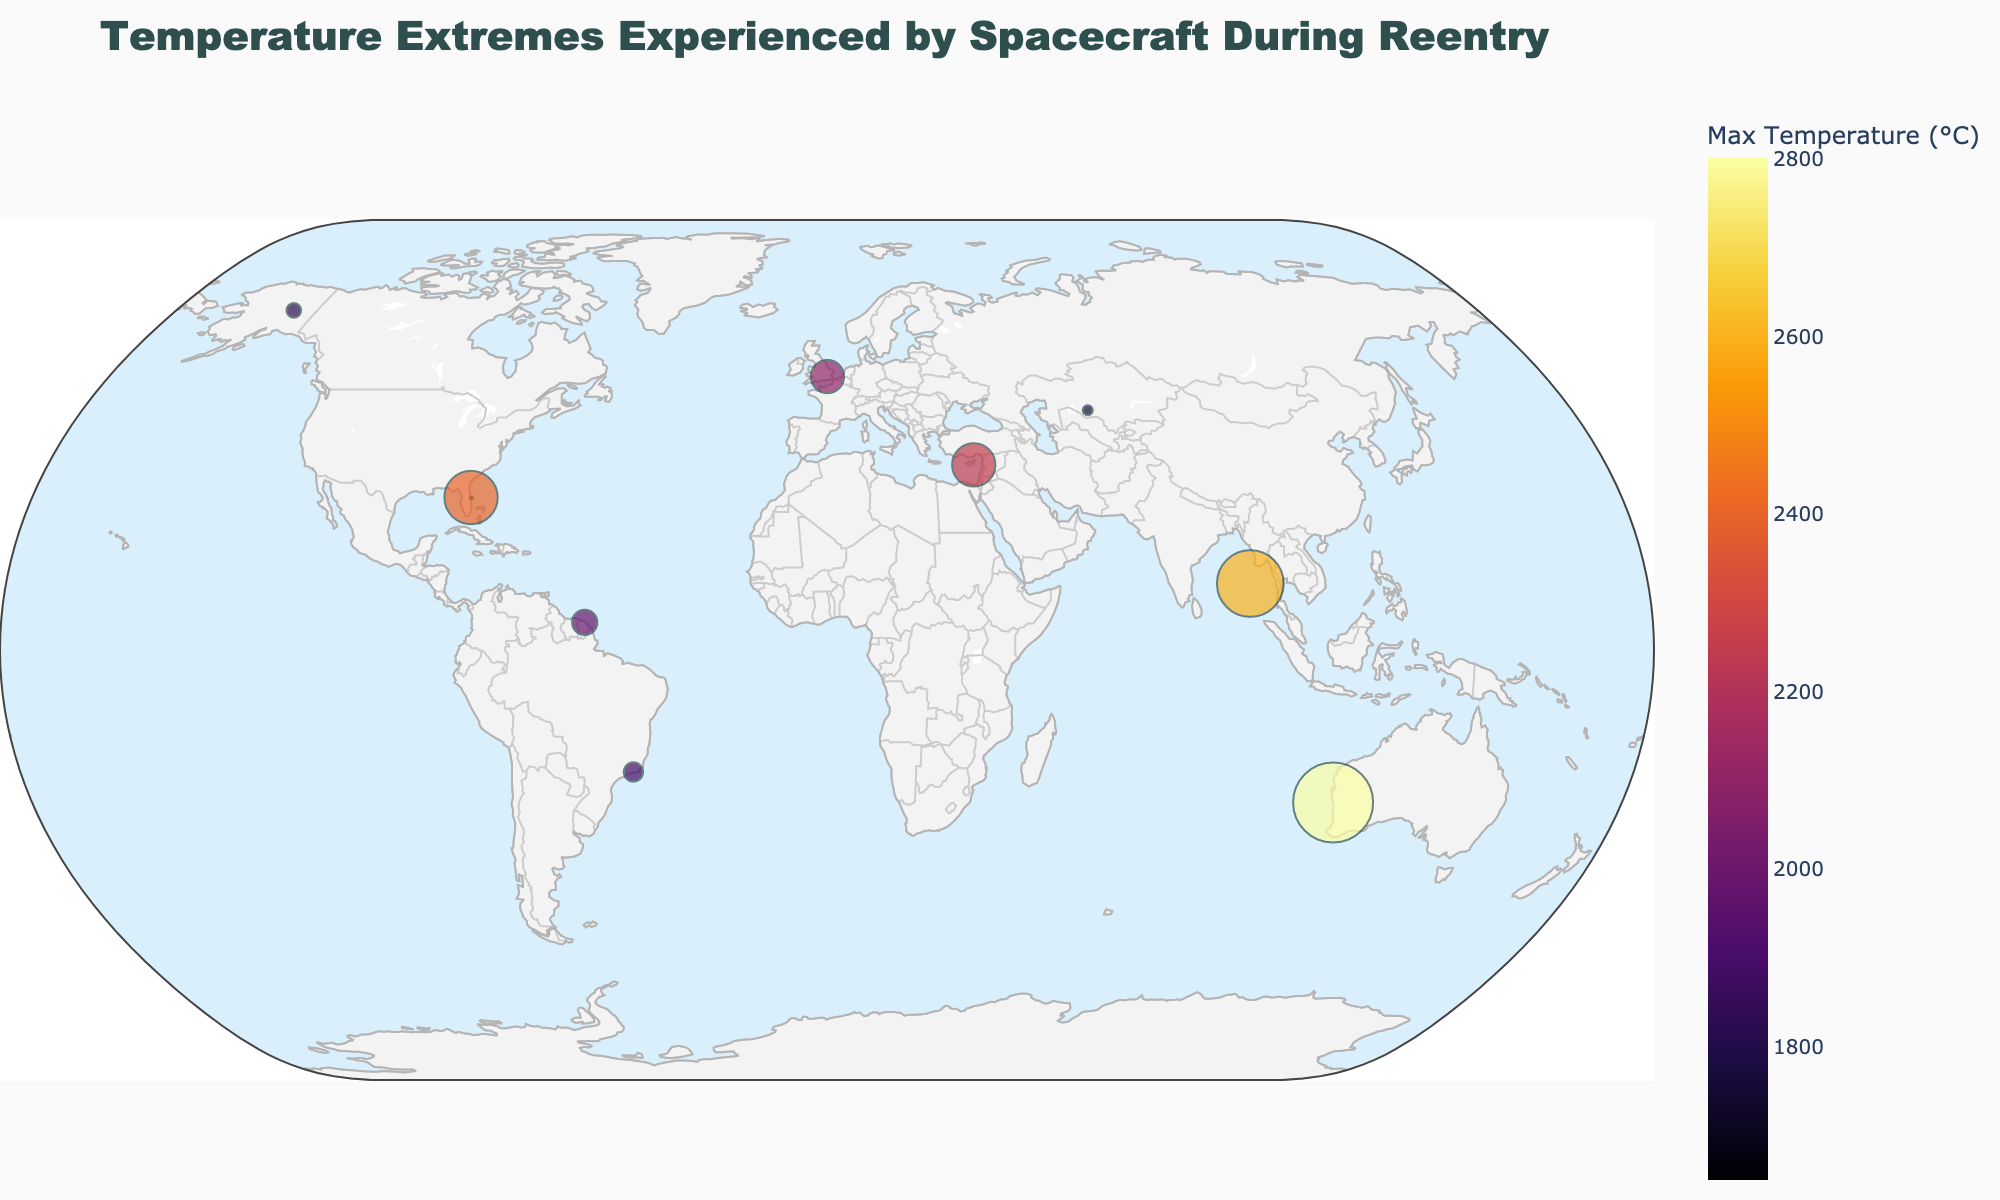What is the title of the plot? The title of the plot is displayed prominently at the top of the figure. It reads "Temperature Extremes Experienced by Spacecraft During Reentry".
Answer: Temperature Extremes Experienced by Spacecraft During Reentry Which orbital path experiences the highest maximum temperature? By examining the plot, we see that the "Mercury Probe Return" datapoint has the highest maximum temperature indicated by the color and the text information.
Answer: Mercury Probe Return How many data points are plotted on the map? We can count the number of markers on the plot, or refer to the data table provided, which lists 10 different orbital paths.
Answer: 10 Which orbital path has the lowest maximum temperature and what is that temperature? The "Low Earth Orbit" has the lowest maximum temperature, as indicated by the plot markers and the text, which shows the lowest value of 1650°C.
Answer: Low Earth Orbit, 1650°C What is the color scale used to represent the temperatures? The figure uses an 'Inferno' color scale to represent the temperatures, transitioning from dark to light colors as the temperature increases.
Answer: Inferno What is the difference in maximum temperature between the "Venus Flyby" and the "Geostationary Transfer Orbit"? From the text information on the plot, "Venus Flyby" has a maximum temperature of 2600°C and "Geostationary Transfer Orbit" has 1980°C. The difference can be calculated as 2600 - 1980.
Answer: 620°C Which three orbital paths have temperatures higher than 2000°C? By analyzing the markers and their respective temperature information on the plot, we identify "Lunar Transfer Orbit" (2250°C), "Mars Transfer Orbit" (2400°C), "Venus Flyby" (2600°C), and "Mercury Probe Return" (2800°C). Therefore, three of these include "Lunar Transfer Orbit", "Mars Transfer Orbit", and "Venus Flyby".
Answer: Lunar Transfer Orbit, Mars Transfer Orbit, Venus Flyby What is the average temperature of the orbital paths? Summing the maximum temperatures from the data and dividing by the number of data points (10): (1650 + 1820 + 1750 + 1980 + 1890 + 2100 + 2250 + 2400 + 2600 + 2800)/10. The exact calculations: the sum is 21240, and 21240/10 is 2124.
Answer: 2124°C What geographical features are indicated on the map? The map shows various features including land, ocean, coastlines, and country borders. These are represented by different colors and lines for easy differentiation.
Answer: Land, ocean, coastlines, country borders 